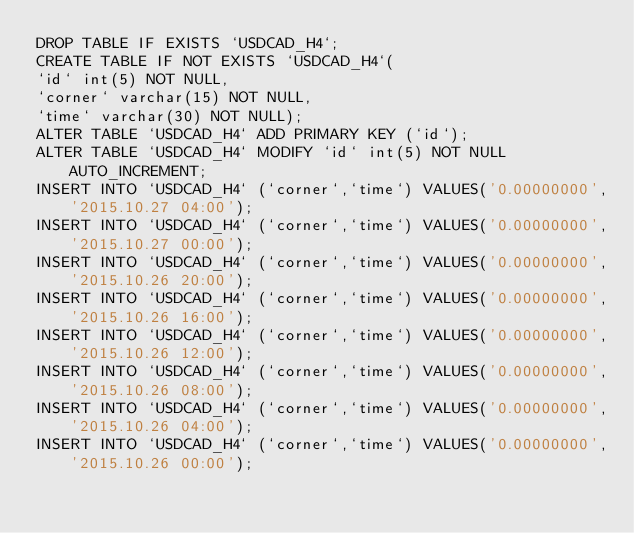Convert code to text. <code><loc_0><loc_0><loc_500><loc_500><_SQL_>DROP TABLE IF EXISTS `USDCAD_H4`;
CREATE TABLE IF NOT EXISTS `USDCAD_H4`(
`id` int(5) NOT NULL,
`corner` varchar(15) NOT NULL,
`time` varchar(30) NOT NULL);
ALTER TABLE `USDCAD_H4` ADD PRIMARY KEY (`id`);
ALTER TABLE `USDCAD_H4` MODIFY `id` int(5) NOT NULL AUTO_INCREMENT;
INSERT INTO `USDCAD_H4` (`corner`,`time`) VALUES('0.00000000','2015.10.27 04:00');
INSERT INTO `USDCAD_H4` (`corner`,`time`) VALUES('0.00000000','2015.10.27 00:00');
INSERT INTO `USDCAD_H4` (`corner`,`time`) VALUES('0.00000000','2015.10.26 20:00');
INSERT INTO `USDCAD_H4` (`corner`,`time`) VALUES('0.00000000','2015.10.26 16:00');
INSERT INTO `USDCAD_H4` (`corner`,`time`) VALUES('0.00000000','2015.10.26 12:00');
INSERT INTO `USDCAD_H4` (`corner`,`time`) VALUES('0.00000000','2015.10.26 08:00');
INSERT INTO `USDCAD_H4` (`corner`,`time`) VALUES('0.00000000','2015.10.26 04:00');
INSERT INTO `USDCAD_H4` (`corner`,`time`) VALUES('0.00000000','2015.10.26 00:00');</code> 